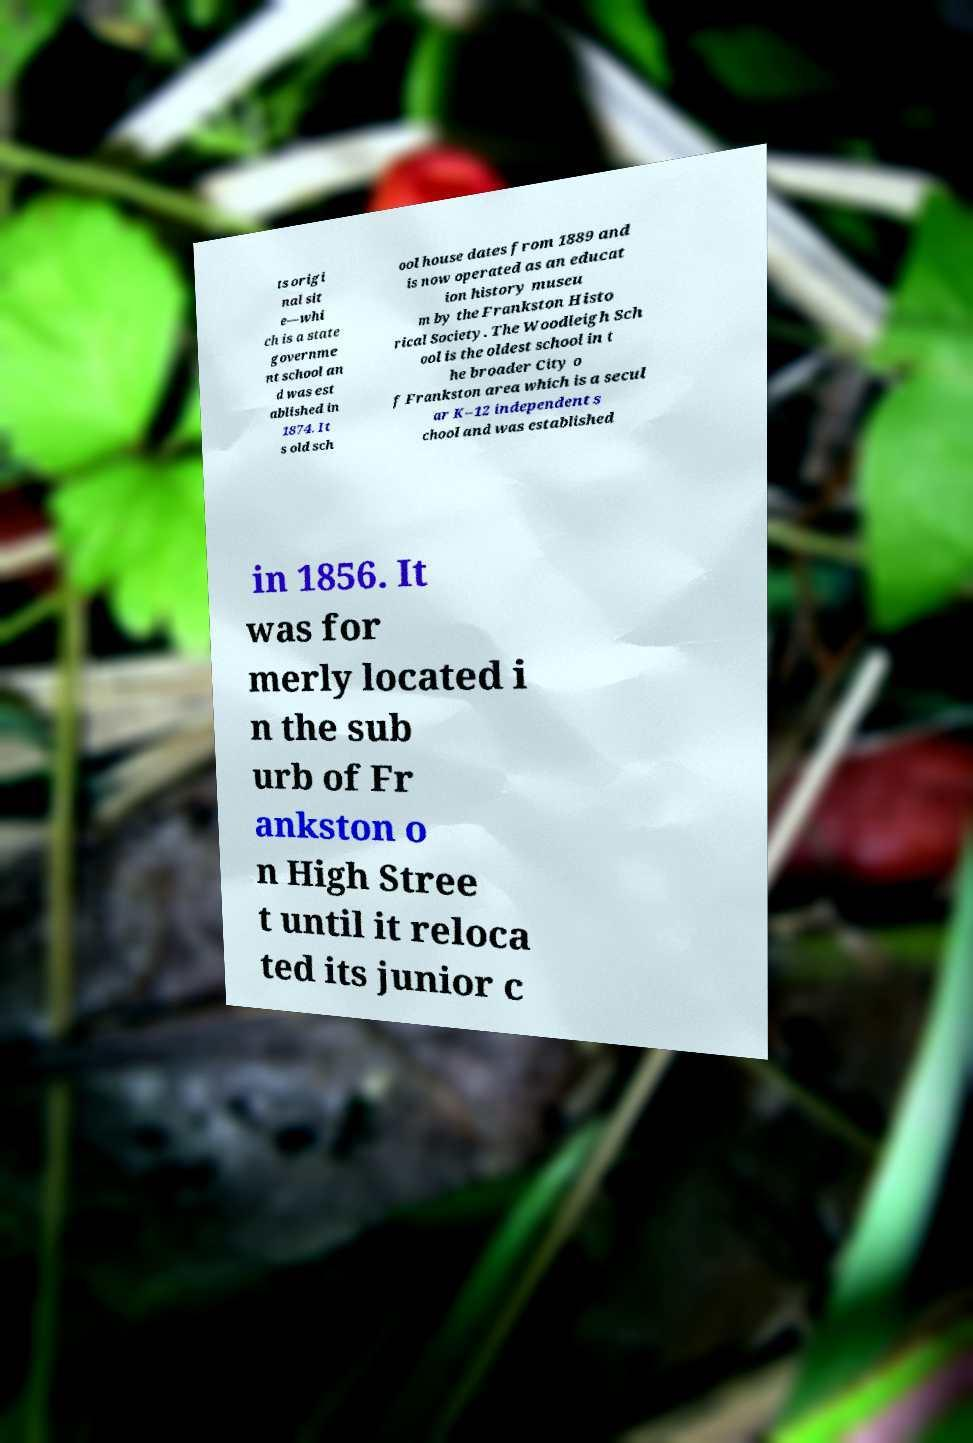Could you assist in decoding the text presented in this image and type it out clearly? ts origi nal sit e—whi ch is a state governme nt school an d was est ablished in 1874. It s old sch ool house dates from 1889 and is now operated as an educat ion history museu m by the Frankston Histo rical Society. The Woodleigh Sch ool is the oldest school in t he broader City o f Frankston area which is a secul ar K–12 independent s chool and was established in 1856. It was for merly located i n the sub urb of Fr ankston o n High Stree t until it reloca ted its junior c 